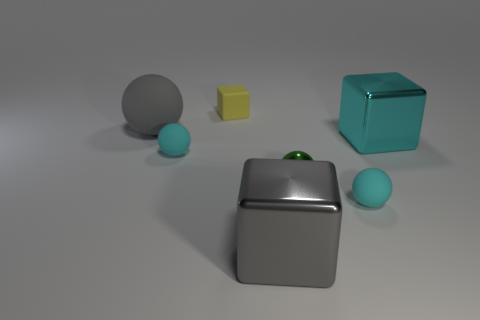There is a object that is on the left side of the tiny yellow cube and in front of the big gray matte thing; what is its material?
Give a very brief answer. Rubber. The metal sphere is what color?
Keep it short and to the point. Green. How many other things are there of the same shape as the yellow thing?
Offer a terse response. 2. Are there the same number of large matte things that are behind the gray matte sphere and cyan matte things that are behind the green ball?
Give a very brief answer. No. What is the material of the small green object?
Offer a terse response. Metal. What is the tiny sphere that is on the right side of the green metal object made of?
Ensure brevity in your answer.  Rubber. Is there any other thing that has the same material as the gray block?
Your answer should be compact. Yes. Is the number of cyan blocks on the left side of the yellow thing greater than the number of large brown matte things?
Keep it short and to the point. No. There is a matte sphere that is to the right of the tiny rubber ball to the left of the yellow rubber block; is there a big cyan metal cube that is behind it?
Keep it short and to the point. Yes. Are there any small yellow matte objects behind the yellow thing?
Provide a short and direct response. No. 